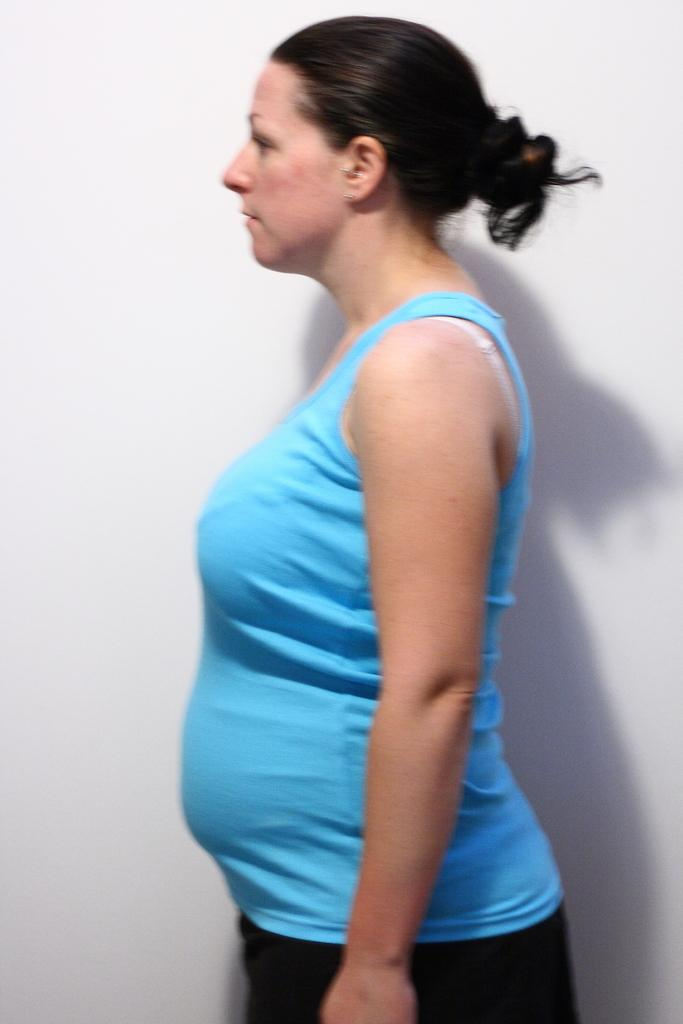Who or what is the main subject of the image? There is a person in the image. Can you describe the person's position in relation to the image? The person is in front of the image. What can be seen behind the person? There is a wall behind the person. How many oranges are being sorted by the person in the image? There are no oranges present in the image, and the person is not sorting anything. What type of business is being conducted by the person in the image? There is no indication of any business activity in the image; it simply shows a person standing in front of a wall. 